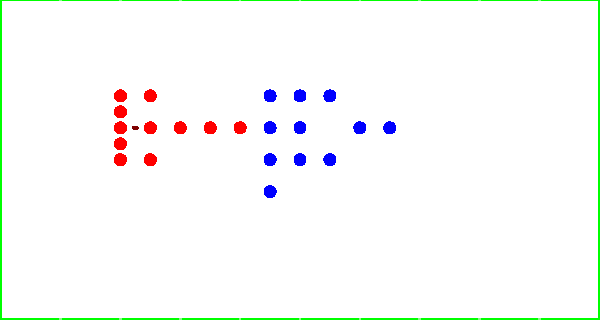Based on the overhead field diagram shown, which type of football play is most likely being set up by the offense? To determine the most likely play type, let's analyze the formation:

1. Offensive formation:
   - 5 players lined up on the line of scrimmage (20-yard line)
   - 3 players in the backfield, slightly behind the line
   - 3 players spread out wider (at 25, 30, and 35-yard lines)

2. Ball position:
   - Located at the 22.5-yard line, suggesting it's in the quarterback's hands

3. Defensive alignment:
   - Spread out to cover both run and pass options

4. Key observations:
   - The presence of multiple receivers spread out wide
   - A quarterback in shotgun formation (indicated by ball position)
   - Running backs in the backfield for potential protection or route-running

5. Conclusion:
   This formation is typical of a spread offense, which is often used for passing plays. The multiple receiving options and the quarterback in shotgun suggest a higher likelihood of a passing play rather than a run.

Given these factors, the most likely play type being set up is a passing play from a spread formation.
Answer: Passing play 